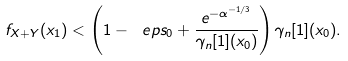Convert formula to latex. <formula><loc_0><loc_0><loc_500><loc_500>f _ { X + Y } ( x _ { 1 } ) < \left ( 1 - \ e p s _ { 0 } + \frac { e ^ { - \alpha ^ { - 1 / 3 } } } { \gamma _ { n } [ 1 ] ( x _ { 0 } ) } \right ) \gamma _ { n } [ 1 ] ( x _ { 0 } ) .</formula> 